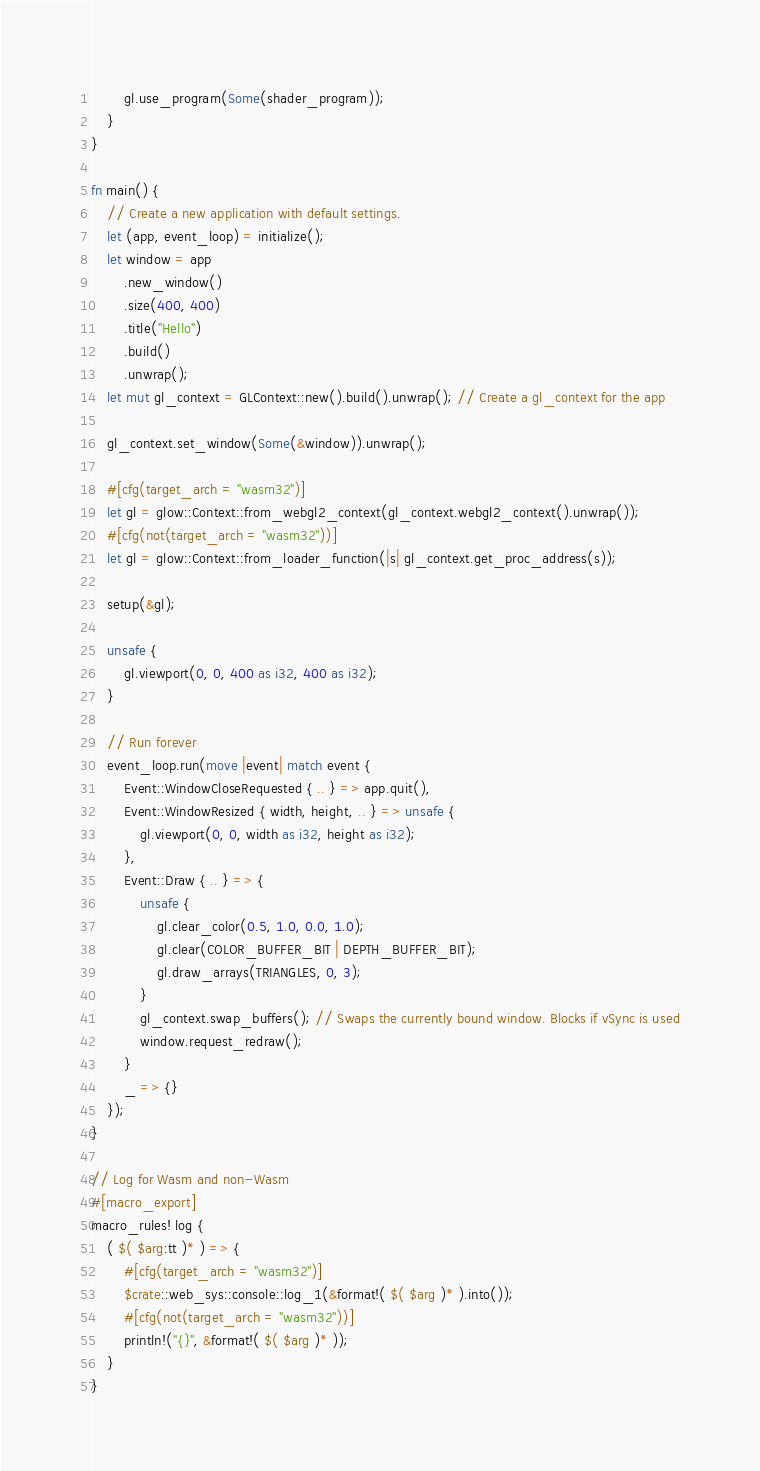Convert code to text. <code><loc_0><loc_0><loc_500><loc_500><_Rust_>        gl.use_program(Some(shader_program));
    }
}

fn main() {
    // Create a new application with default settings.
    let (app, event_loop) = initialize();
    let window = app
        .new_window()
        .size(400, 400)
        .title("Hello")
        .build()
        .unwrap();
    let mut gl_context = GLContext::new().build().unwrap(); // Create a gl_context for the app

    gl_context.set_window(Some(&window)).unwrap();

    #[cfg(target_arch = "wasm32")]
    let gl = glow::Context::from_webgl2_context(gl_context.webgl2_context().unwrap());
    #[cfg(not(target_arch = "wasm32"))]
    let gl = glow::Context::from_loader_function(|s| gl_context.get_proc_address(s));

    setup(&gl);

    unsafe {
        gl.viewport(0, 0, 400 as i32, 400 as i32);
    }

    // Run forever
    event_loop.run(move |event| match event {
        Event::WindowCloseRequested { .. } => app.quit(),
        Event::WindowResized { width, height, .. } => unsafe {
            gl.viewport(0, 0, width as i32, height as i32);
        },
        Event::Draw { .. } => {
            unsafe {
                gl.clear_color(0.5, 1.0, 0.0, 1.0);
                gl.clear(COLOR_BUFFER_BIT | DEPTH_BUFFER_BIT);
                gl.draw_arrays(TRIANGLES, 0, 3);
            }
            gl_context.swap_buffers(); // Swaps the currently bound window. Blocks if vSync is used
            window.request_redraw();
        }
        _ => {}
    });
}

// Log for Wasm and non-Wasm
#[macro_export]
macro_rules! log {
    ( $( $arg:tt )* ) => {
        #[cfg(target_arch = "wasm32")]
        $crate::web_sys::console::log_1(&format!( $( $arg )* ).into());
        #[cfg(not(target_arch = "wasm32"))]
        println!("{}", &format!( $( $arg )* ));
    }
}
</code> 